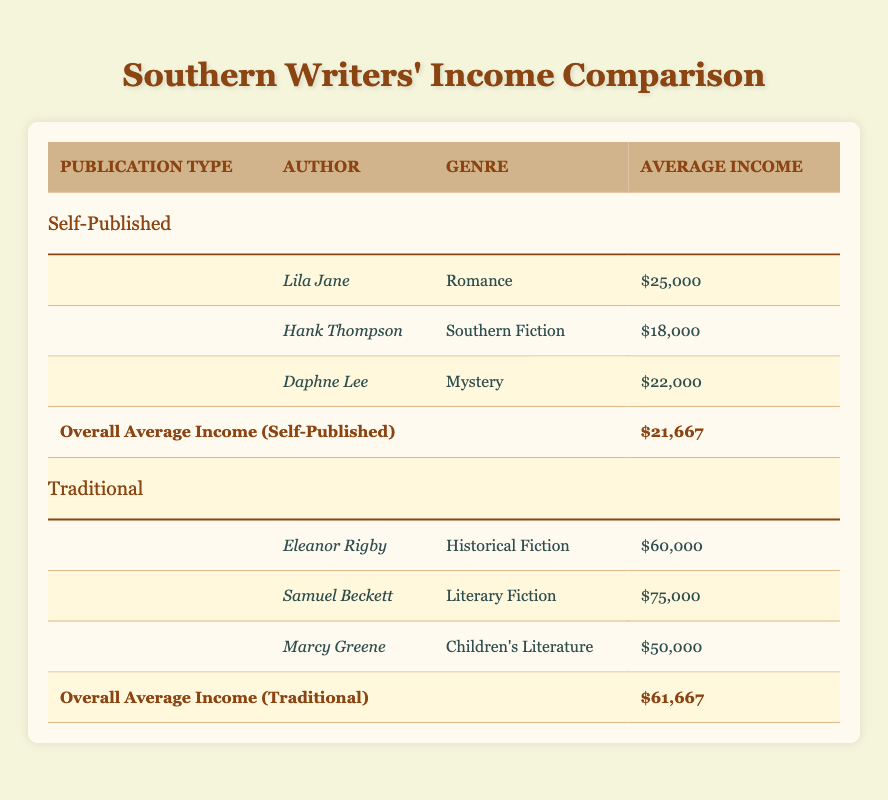What is the overall average income for self-published authors? The table lists the overall average income for self-published authors in the last row under "Self-Published," which states that the overall average income is $21,667.
Answer: $21,667 Who earned the highest income among traditional authors? By reviewing the average income for traditional authors, Samuel Beckett is listed with an average income of $75,000, which is the highest among the traditional authors.
Answer: Samuel Beckett What is the difference in average income between self-published and traditional authors? The overall average income for traditional authors is $61,667, while the overall average income for self-published authors is $21,667. The difference is calculated as $61,667 - $21,667 = $40,000.
Answer: $40,000 Is it true that all traditional authors earn more than $40,000? By checking the average incomes of traditional authors, Eleanor Rigby earns $60,000, Samuel Beckett earns $75,000, and Marcy Greene earns $50,000. Since all these values are above $40,000, the statement is true.
Answer: Yes What is the average income for authors in the Mystery genre? According to the table, Daphne Lee, who writes in the Mystery genre, is a self-published author with an average income of $22,000. There are no traditional authors in this genre, so $22,000 is the average income for authors in the Mystery genre.
Answer: $22,000 If we combine the average incomes of both self-published and traditional authors, what would be the overall average? The overall average for self-published authors is $21,667, and for traditional authors, it is $61,667. To find the combined average, we sum the overall averages and divide by the number of groups: ($21,667 + $61,667) / 2 = $41,667.
Answer: $41,667 Who has the lowest average income among self-published authors? The table shows that Hank Thompson has the lowest average income among self-published authors with an income of $18,000.
Answer: Hank Thompson Which genre has the highest average income among self-published authors? Analyzing the average incomes of self-published authors: Lila Jane (Romance) earns $25,000, Hank Thompson (Southern Fiction) earns $18,000, and Daphne Lee (Mystery) earns $22,000. The highest is $25,000 from Lila Jane in the Romance genre.
Answer: Romance genre 